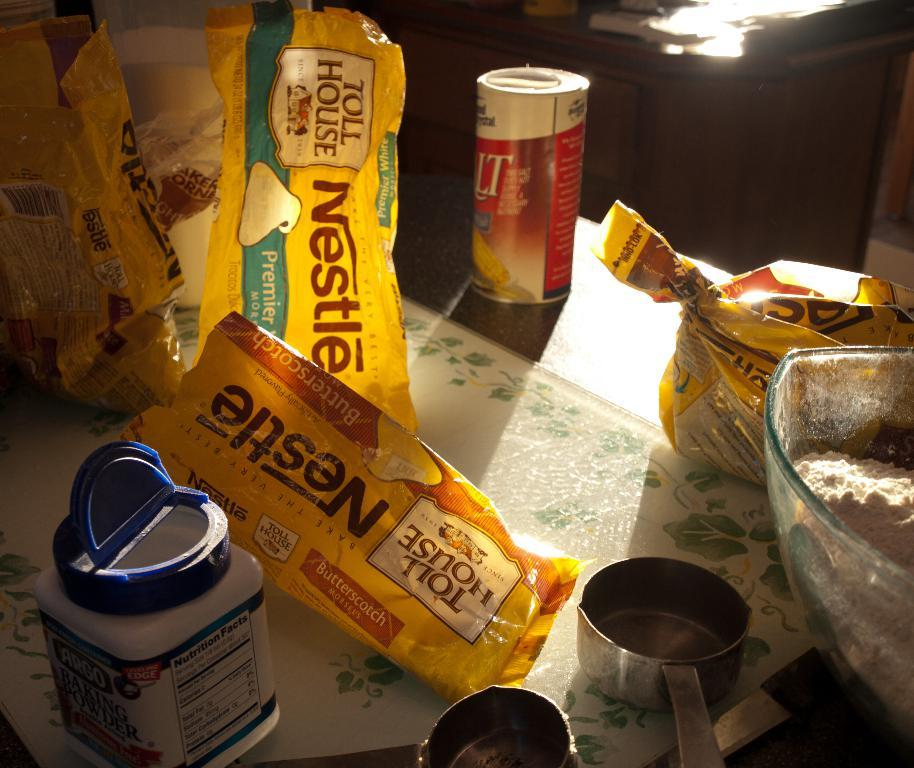<image>
Offer a succinct explanation of the picture presented. Ingredients on a table including Nestle Toll House morsels. 